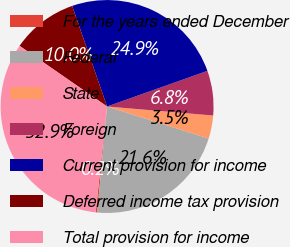<chart> <loc_0><loc_0><loc_500><loc_500><pie_chart><fcel>For the years ended December<fcel>Federal<fcel>State<fcel>Foreign<fcel>Current provision for income<fcel>Deferred income tax provision<fcel>Total provision for income<nl><fcel>0.24%<fcel>21.62%<fcel>3.51%<fcel>6.78%<fcel>24.89%<fcel>10.04%<fcel>32.93%<nl></chart> 